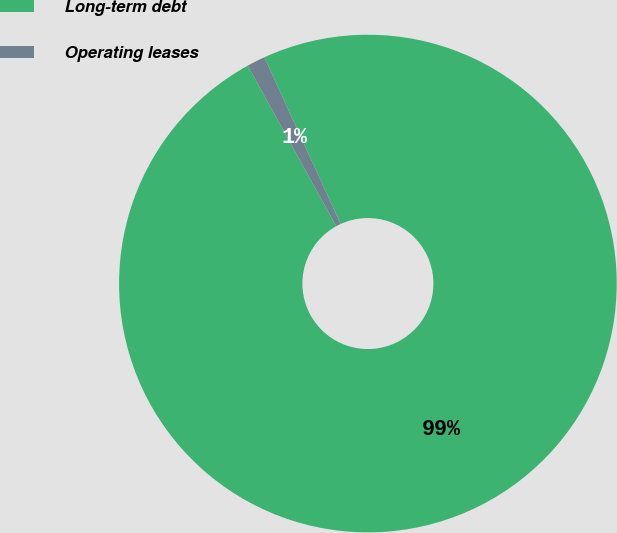Convert chart to OTSL. <chart><loc_0><loc_0><loc_500><loc_500><pie_chart><fcel>Long-term debt<fcel>Operating leases<nl><fcel>98.81%<fcel>1.19%<nl></chart> 